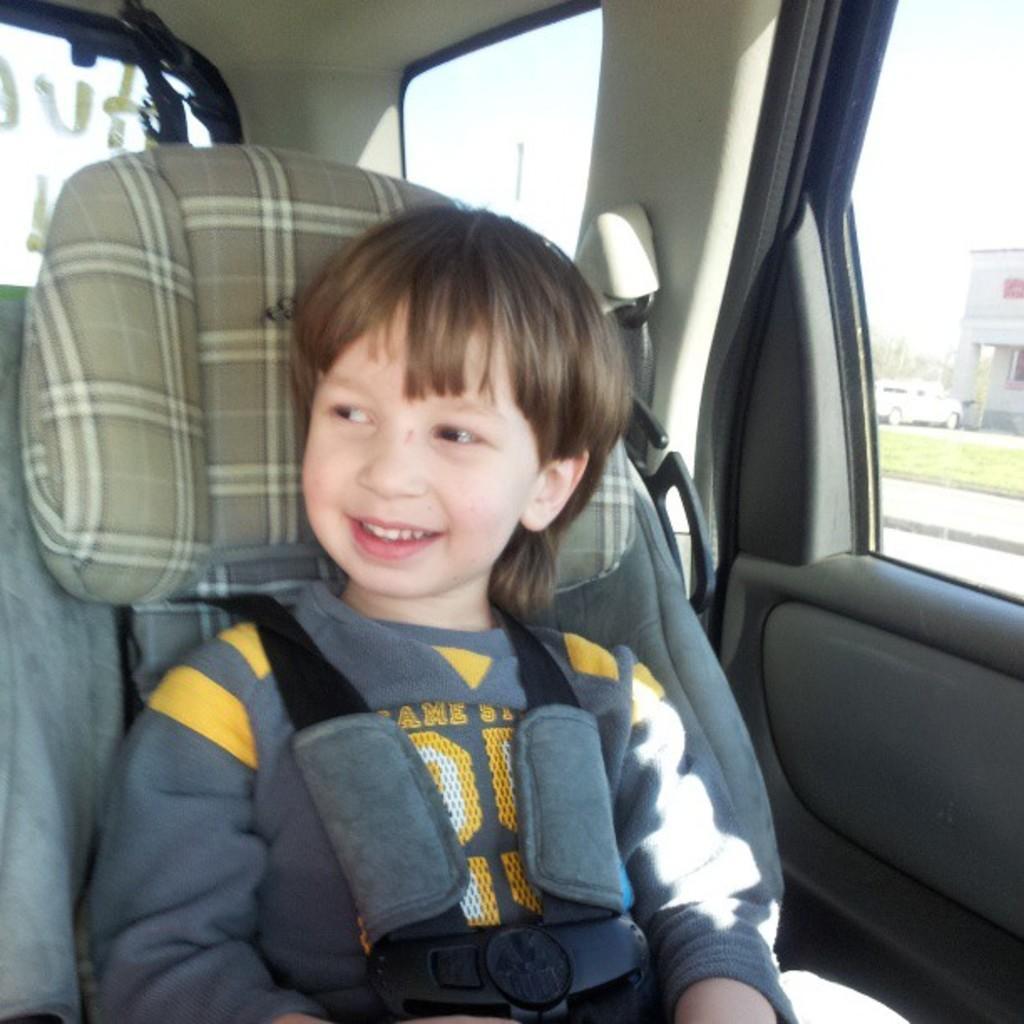Please provide a concise description of this image. This kid is sitting inside of a car. Outside of this window there is a vehicle, building and grass. 